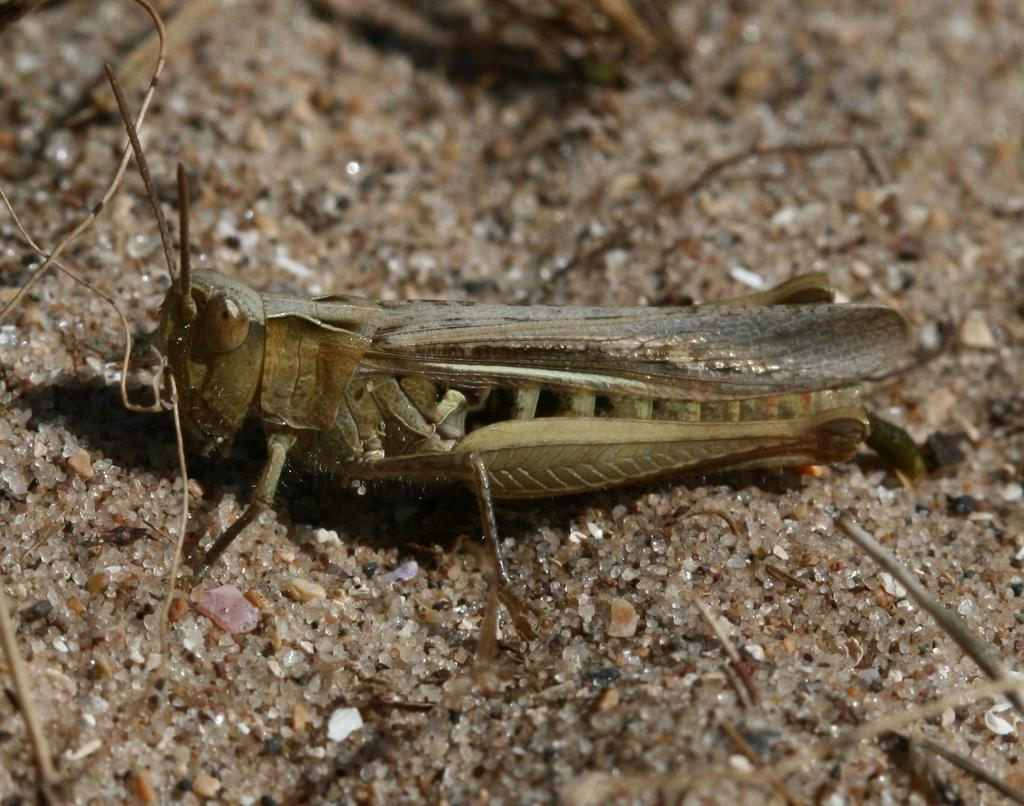Where was the image taken? The image is taken outdoors. What type of terrain is visible at the bottom of the image? There is sand at the bottom of the image. What can be seen in the middle of the image? There is a grasshopper in the middle of the image. Where is the grasshopper located in the image? The grasshopper is on the sand. What type of milk is being served on the calendar in the image? There is no milk or calendar present in the image; it features a grasshopper on sand. 